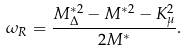<formula> <loc_0><loc_0><loc_500><loc_500>\omega _ { R } = \frac { M _ { \Delta } ^ { \ast 2 } - M ^ { \ast 2 } - K _ { \mu } ^ { 2 } } { 2 M ^ { \ast } } .</formula> 